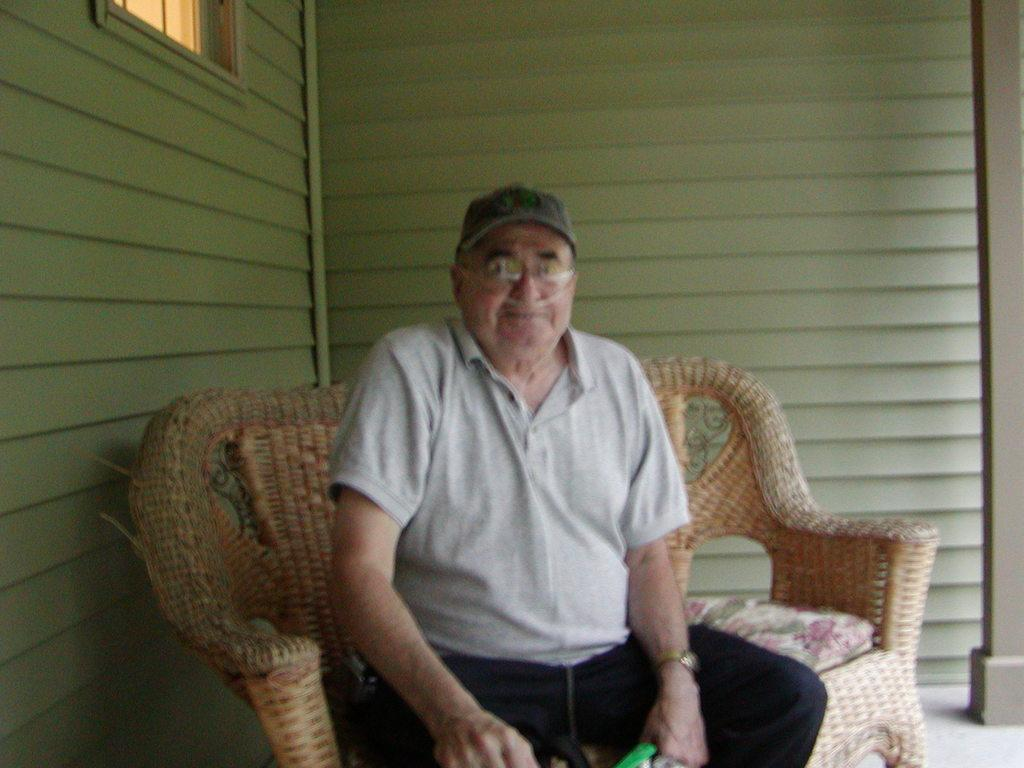What is the person in the image doing? There is a person sitting on the couch in the image. What can be seen behind the person? There is a wall behind the person. What is a feature of the room visible in the image? There is a window in the image. What part of the room is visible at the bottom of the image? The floor is visible at the bottom of the image. What type of songs can be heard coming from the person in the image? There is no indication in the image that the person is singing or playing music, so it's not possible to determine what songs might be heard. 